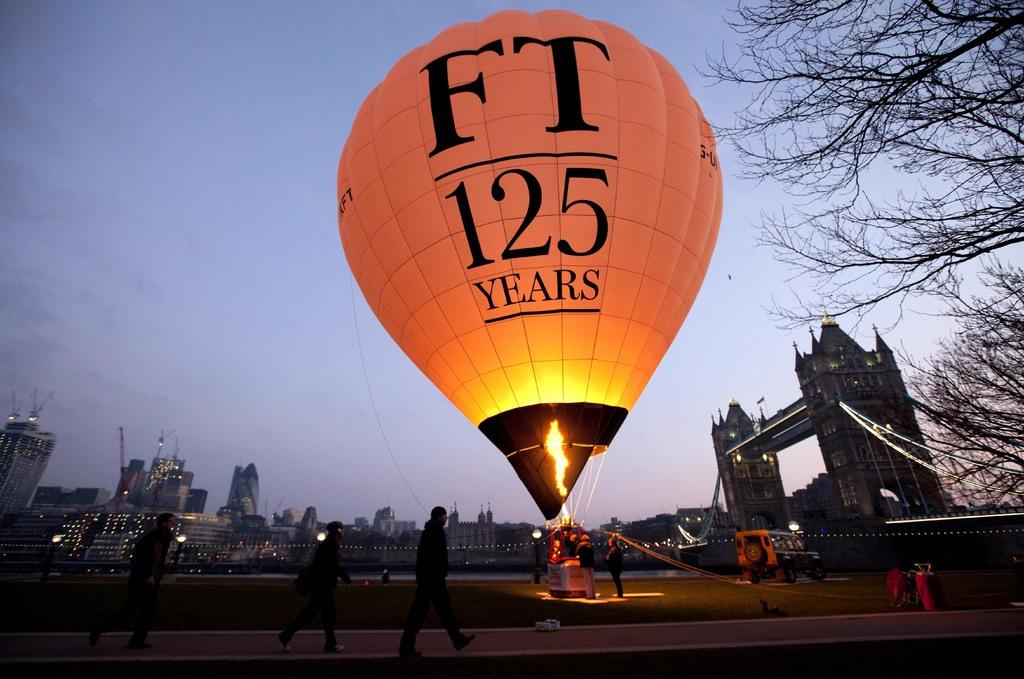<image>
Summarize the visual content of the image. A hot air ballon in the evening that says FT 125 years. 